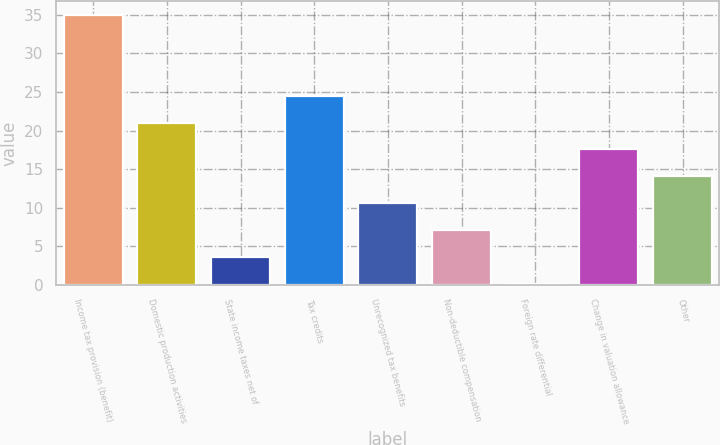Convert chart to OTSL. <chart><loc_0><loc_0><loc_500><loc_500><bar_chart><fcel>Income tax provision (benefit)<fcel>Domestic production activities<fcel>State income taxes net of<fcel>Tax credits<fcel>Unrecognized tax benefits<fcel>Non-deductible compensation<fcel>Foreign rate differential<fcel>Change in valuation allowance<fcel>Other<nl><fcel>35<fcel>21.04<fcel>3.59<fcel>24.53<fcel>10.57<fcel>7.08<fcel>0.1<fcel>17.55<fcel>14.06<nl></chart> 